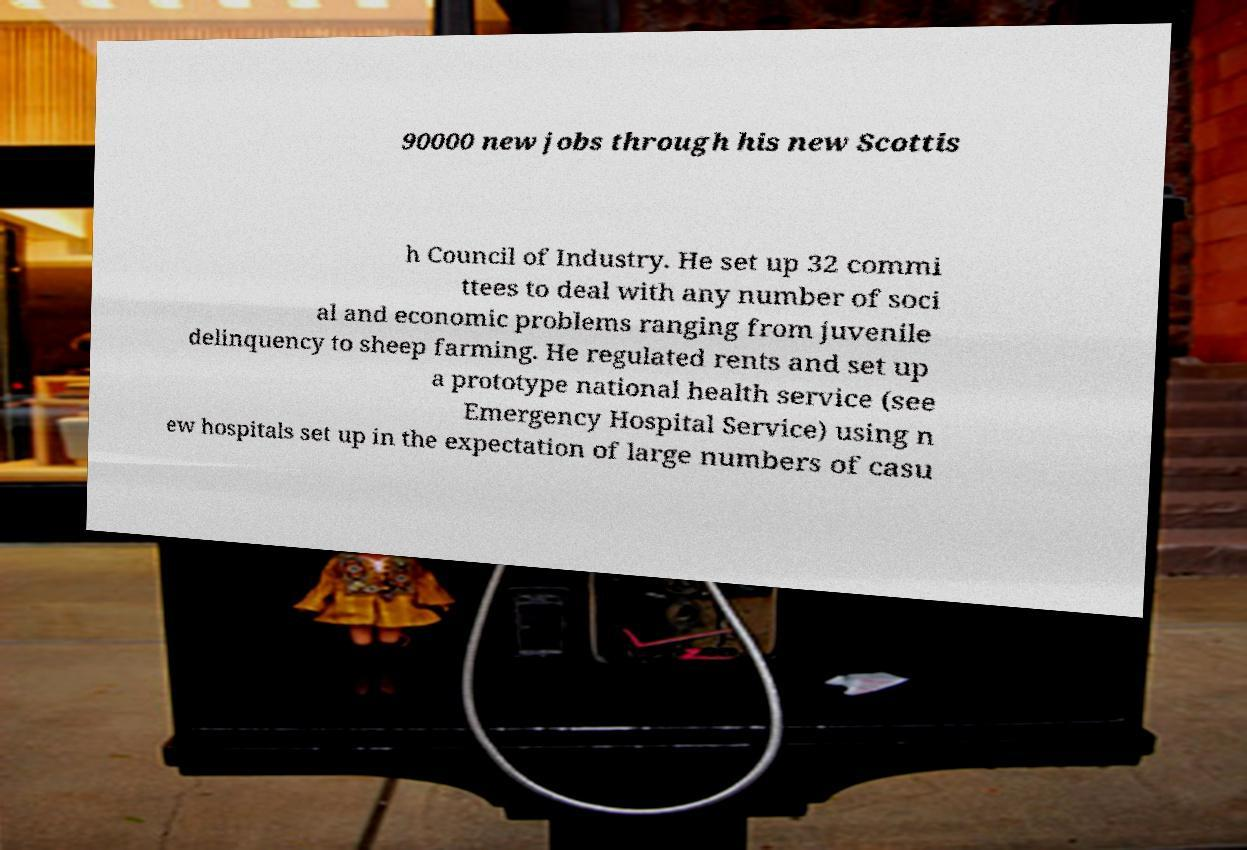There's text embedded in this image that I need extracted. Can you transcribe it verbatim? 90000 new jobs through his new Scottis h Council of Industry. He set up 32 commi ttees to deal with any number of soci al and economic problems ranging from juvenile delinquency to sheep farming. He regulated rents and set up a prototype national health service (see Emergency Hospital Service) using n ew hospitals set up in the expectation of large numbers of casu 